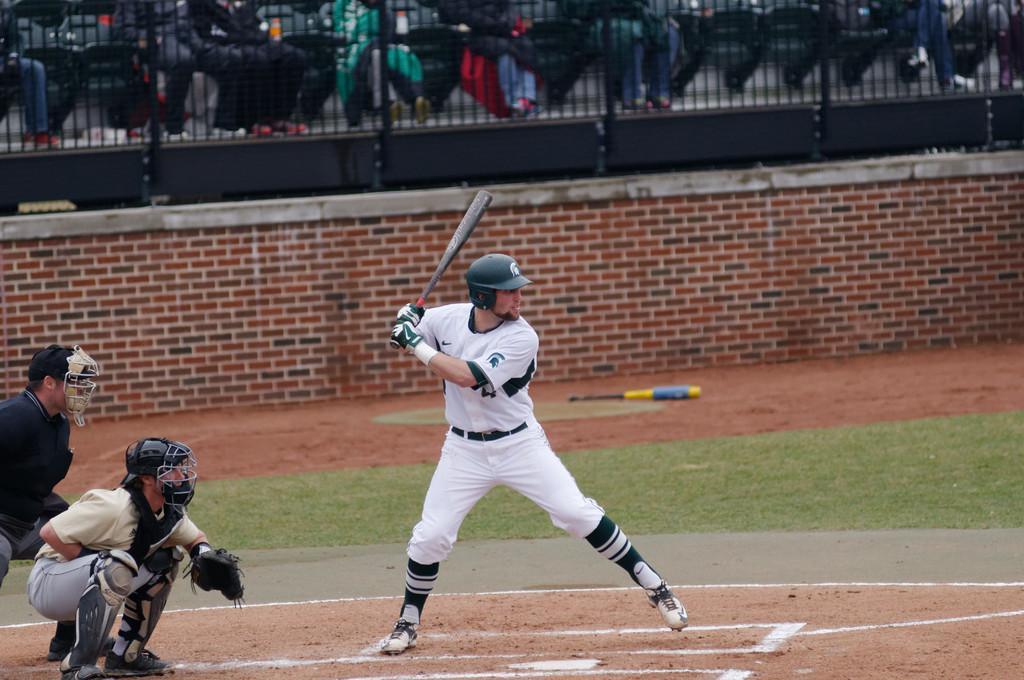Please provide a concise description of this image. In this picture we can see three persons playing baseball game, this man is holding a baseball bat, these three people wore helmets, shoes and gloves, in the background there are some people sitting on chairs, we can see fencing here, at the bottom there is grass. 